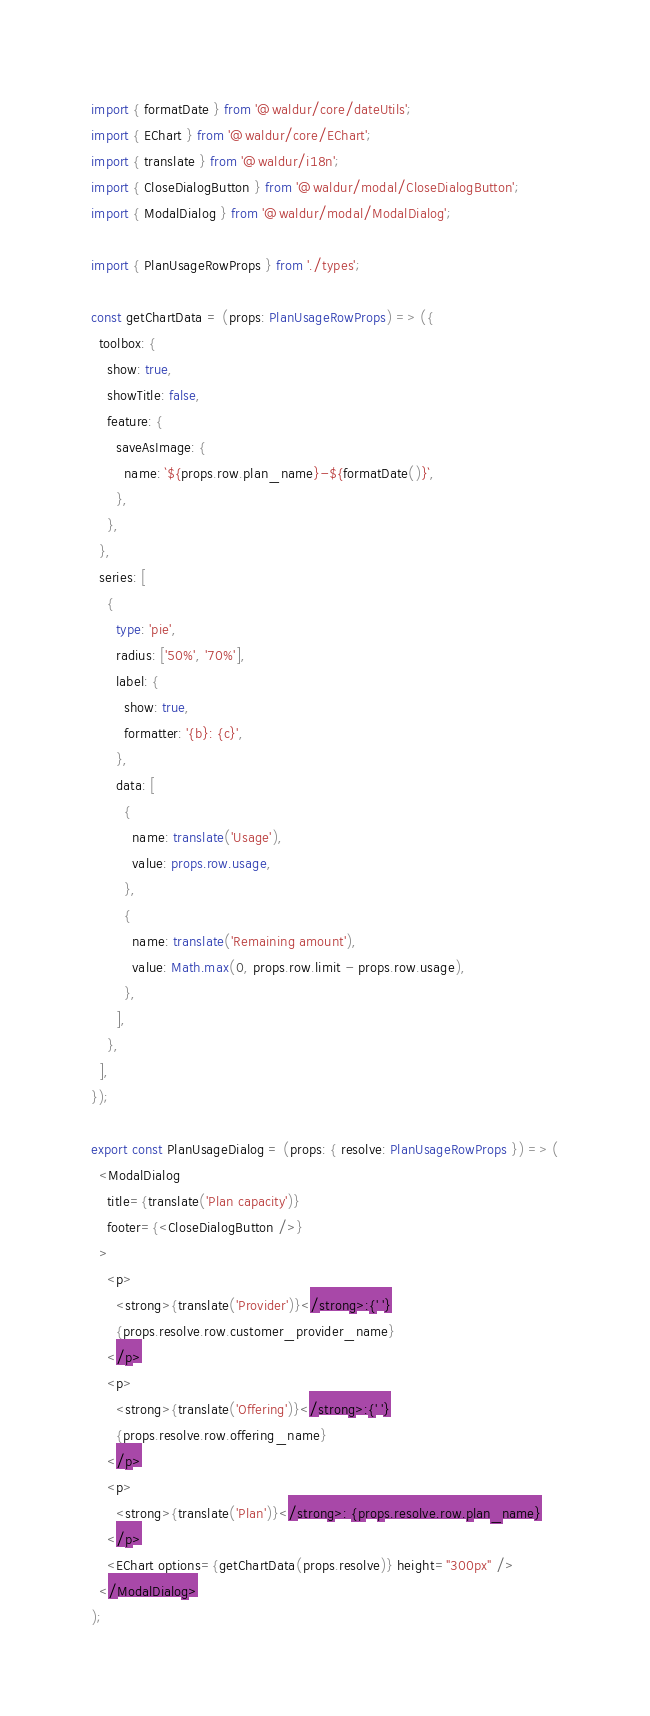<code> <loc_0><loc_0><loc_500><loc_500><_TypeScript_>import { formatDate } from '@waldur/core/dateUtils';
import { EChart } from '@waldur/core/EChart';
import { translate } from '@waldur/i18n';
import { CloseDialogButton } from '@waldur/modal/CloseDialogButton';
import { ModalDialog } from '@waldur/modal/ModalDialog';

import { PlanUsageRowProps } from './types';

const getChartData = (props: PlanUsageRowProps) => ({
  toolbox: {
    show: true,
    showTitle: false,
    feature: {
      saveAsImage: {
        name: `${props.row.plan_name}-${formatDate()}`,
      },
    },
  },
  series: [
    {
      type: 'pie',
      radius: ['50%', '70%'],
      label: {
        show: true,
        formatter: '{b}: {c}',
      },
      data: [
        {
          name: translate('Usage'),
          value: props.row.usage,
        },
        {
          name: translate('Remaining amount'),
          value: Math.max(0, props.row.limit - props.row.usage),
        },
      ],
    },
  ],
});

export const PlanUsageDialog = (props: { resolve: PlanUsageRowProps }) => (
  <ModalDialog
    title={translate('Plan capacity')}
    footer={<CloseDialogButton />}
  >
    <p>
      <strong>{translate('Provider')}</strong>:{' '}
      {props.resolve.row.customer_provider_name}
    </p>
    <p>
      <strong>{translate('Offering')}</strong>:{' '}
      {props.resolve.row.offering_name}
    </p>
    <p>
      <strong>{translate('Plan')}</strong>: {props.resolve.row.plan_name}
    </p>
    <EChart options={getChartData(props.resolve)} height="300px" />
  </ModalDialog>
);
</code> 